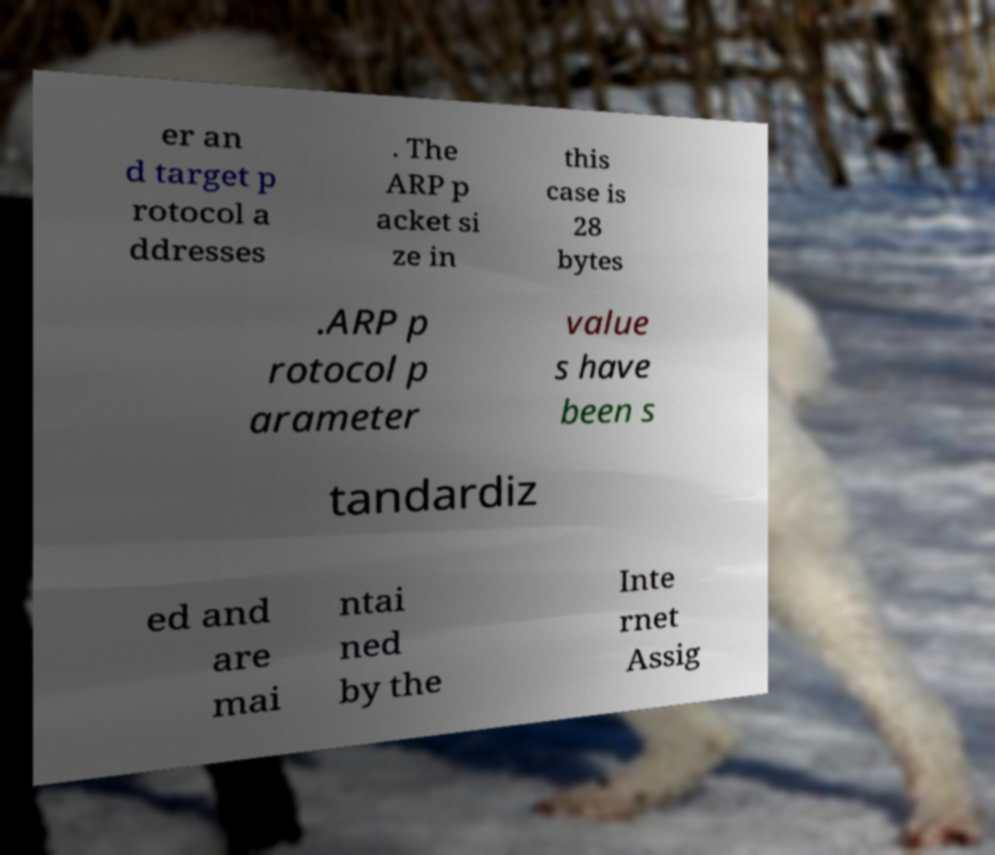Could you extract and type out the text from this image? er an d target p rotocol a ddresses . The ARP p acket si ze in this case is 28 bytes .ARP p rotocol p arameter value s have been s tandardiz ed and are mai ntai ned by the Inte rnet Assig 